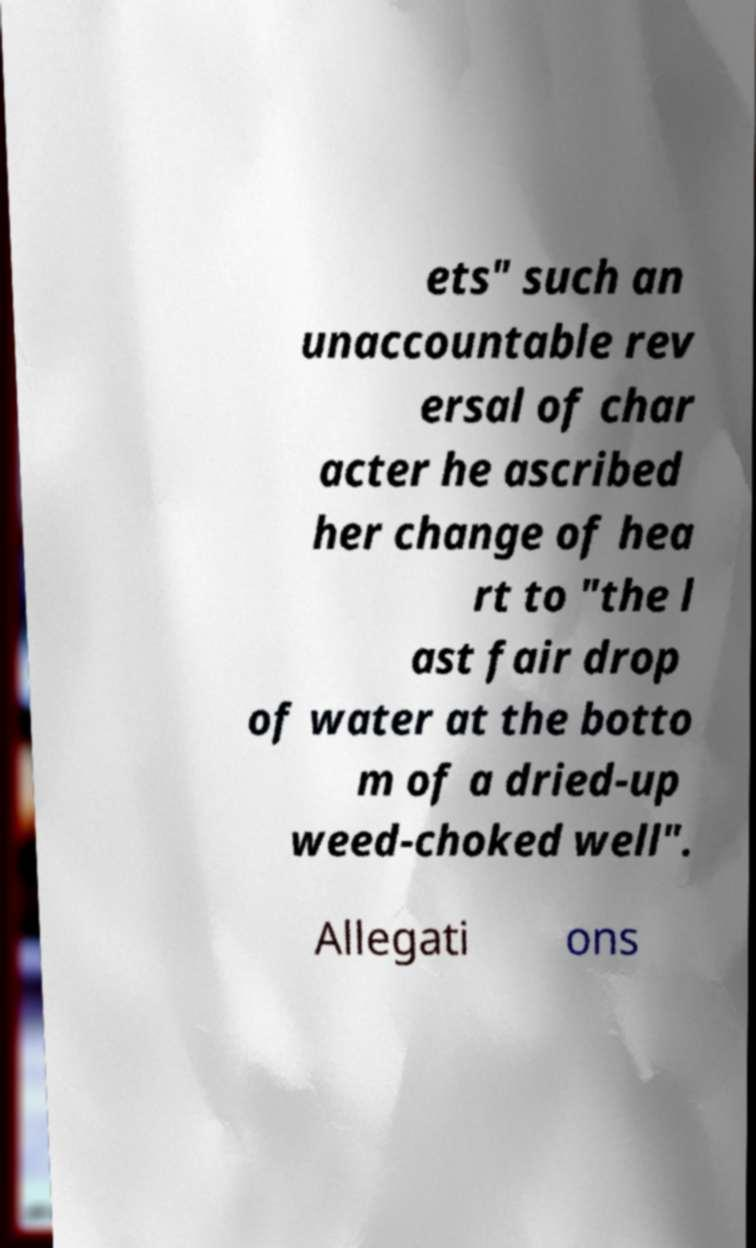Please read and relay the text visible in this image. What does it say? ets" such an unaccountable rev ersal of char acter he ascribed her change of hea rt to "the l ast fair drop of water at the botto m of a dried-up weed-choked well". Allegati ons 